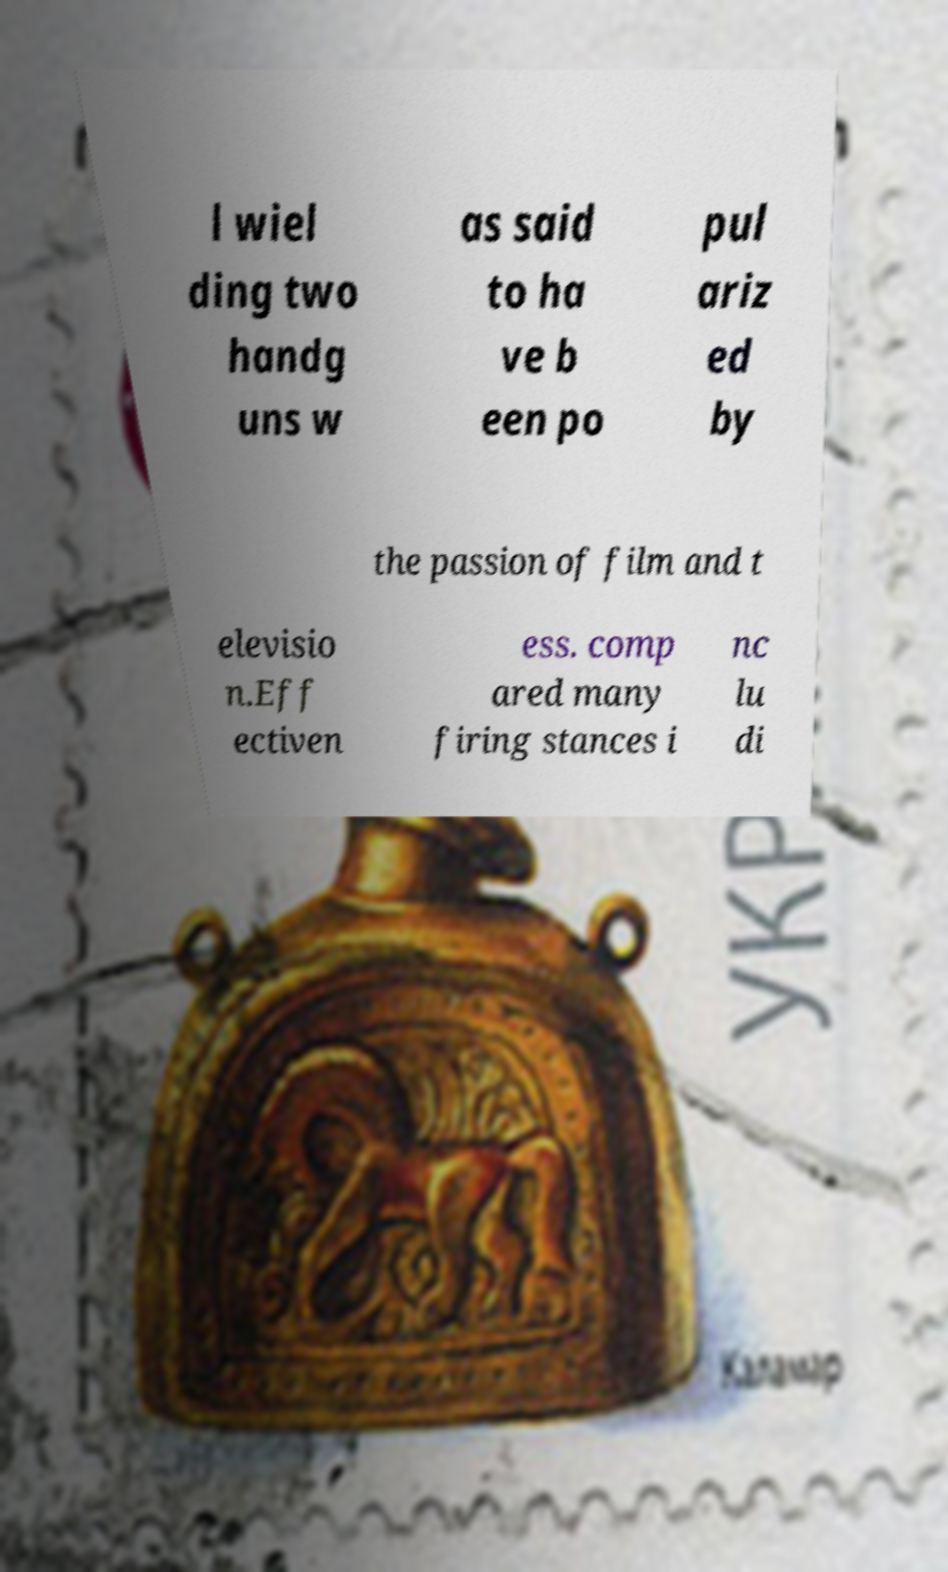Please identify and transcribe the text found in this image. l wiel ding two handg uns w as said to ha ve b een po pul ariz ed by the passion of film and t elevisio n.Eff ectiven ess. comp ared many firing stances i nc lu di 